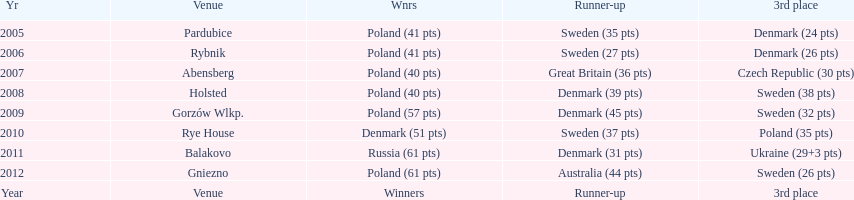What was the difference in final score between russia and denmark in 2011? 30. 